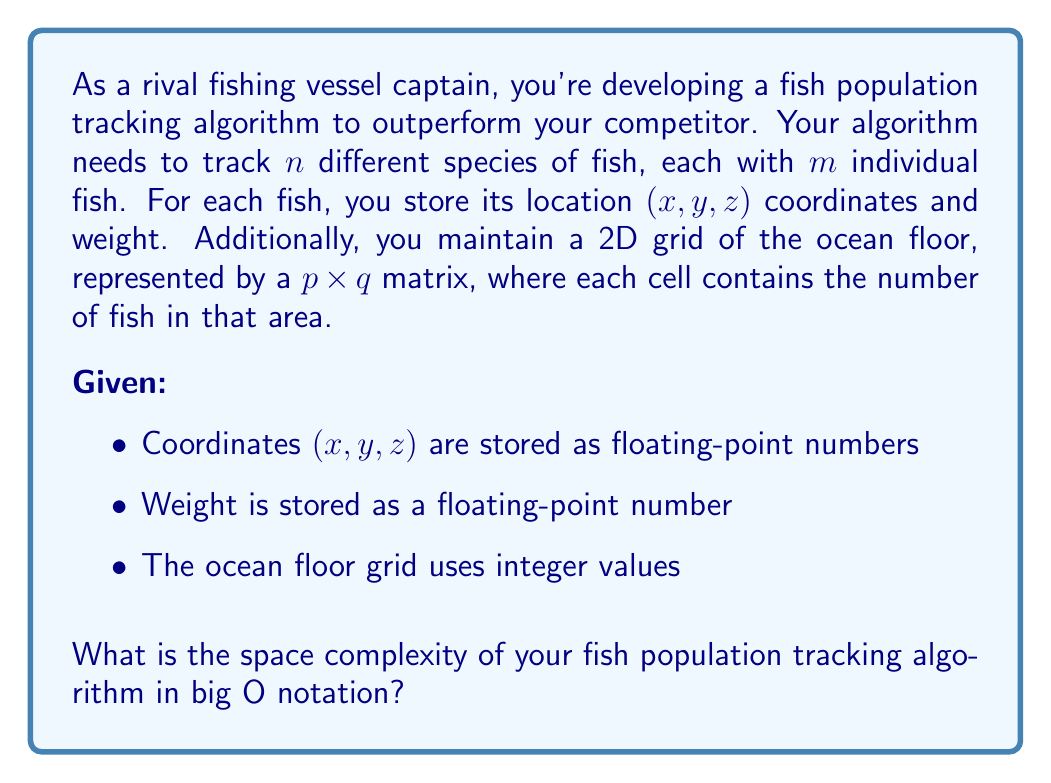Show me your answer to this math problem. Let's break down the space requirements step by step:

1. Storing individual fish data:
   - For each fish: 3 coordinates (x, y, z) and 1 weight = 4 floating-point numbers
   - Total fish: $n \times m$
   - Space for fish data: $O(4nm)$ = $O(nm)$

2. Storing species information:
   - We have $n$ species
   - Assuming we store a constant amount of data per species (e.g., name, average size)
   - Space for species data: $O(n)$

3. Ocean floor grid:
   - Grid size: $p \times q$
   - Each cell contains an integer
   - Space for grid: $O(pq)$

Total space complexity:
$$O(nm + n + pq)$$

We can simplify this further:
- If $nm$ dominates (i.e., number of fish is much larger than the grid size), then the complexity is $O(nm)$
- If $pq$ dominates (i.e., grid size is much larger than the number of fish), then the complexity is $O(pq)$

Therefore, we can express the overall space complexity as:

$$O(\max(nm, pq))$$

This represents the worst-case scenario, where we consider the larger of the two main components: fish data storage or ocean floor grid storage.
Answer: $O(\max(nm, pq))$ 